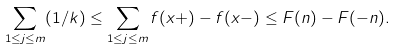<formula> <loc_0><loc_0><loc_500><loc_500>\sum _ { 1 \leq j \leq m } ( 1 / k ) \leq \sum _ { 1 \leq j \leq m } f ( x + ) - f ( x - ) \leq F ( n ) - F ( - n ) .</formula> 